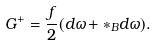Convert formula to latex. <formula><loc_0><loc_0><loc_500><loc_500>G ^ { + } = \frac { f } { 2 } ( d \omega + \ast _ { B } d \omega ) .</formula> 